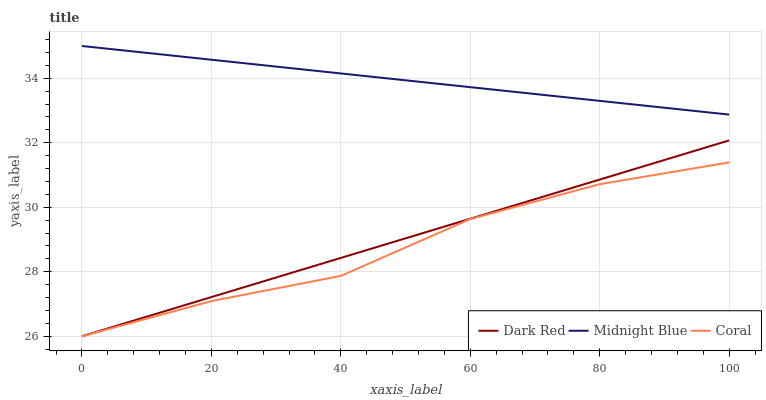Does Midnight Blue have the minimum area under the curve?
Answer yes or no. No. Does Coral have the maximum area under the curve?
Answer yes or no. No. Is Midnight Blue the smoothest?
Answer yes or no. No. Is Midnight Blue the roughest?
Answer yes or no. No. Does Midnight Blue have the lowest value?
Answer yes or no. No. Does Coral have the highest value?
Answer yes or no. No. Is Dark Red less than Midnight Blue?
Answer yes or no. Yes. Is Midnight Blue greater than Dark Red?
Answer yes or no. Yes. Does Dark Red intersect Midnight Blue?
Answer yes or no. No. 